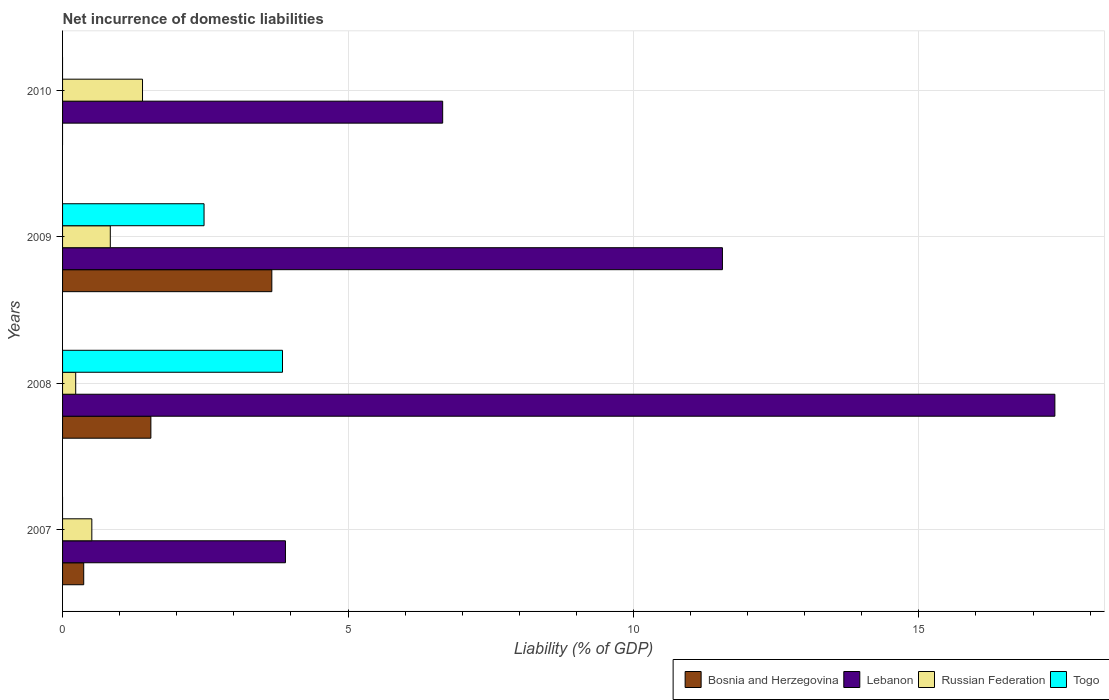Are the number of bars per tick equal to the number of legend labels?
Your answer should be compact. No. How many bars are there on the 3rd tick from the bottom?
Provide a succinct answer. 4. What is the label of the 1st group of bars from the top?
Give a very brief answer. 2010. In how many cases, is the number of bars for a given year not equal to the number of legend labels?
Provide a succinct answer. 2. Across all years, what is the maximum net incurrence of domestic liabilities in Bosnia and Herzegovina?
Your answer should be very brief. 3.67. Across all years, what is the minimum net incurrence of domestic liabilities in Lebanon?
Your response must be concise. 3.9. What is the total net incurrence of domestic liabilities in Bosnia and Herzegovina in the graph?
Your response must be concise. 5.58. What is the difference between the net incurrence of domestic liabilities in Russian Federation in 2007 and that in 2010?
Ensure brevity in your answer.  -0.89. What is the difference between the net incurrence of domestic liabilities in Togo in 2008 and the net incurrence of domestic liabilities in Bosnia and Herzegovina in 2007?
Your answer should be very brief. 3.48. What is the average net incurrence of domestic liabilities in Russian Federation per year?
Provide a short and direct response. 0.74. In the year 2008, what is the difference between the net incurrence of domestic liabilities in Lebanon and net incurrence of domestic liabilities in Togo?
Provide a short and direct response. 13.53. In how many years, is the net incurrence of domestic liabilities in Lebanon greater than 5 %?
Keep it short and to the point. 3. What is the ratio of the net incurrence of domestic liabilities in Bosnia and Herzegovina in 2007 to that in 2009?
Your answer should be compact. 0.1. What is the difference between the highest and the second highest net incurrence of domestic liabilities in Bosnia and Herzegovina?
Keep it short and to the point. 2.12. What is the difference between the highest and the lowest net incurrence of domestic liabilities in Lebanon?
Provide a succinct answer. 13.48. In how many years, is the net incurrence of domestic liabilities in Lebanon greater than the average net incurrence of domestic liabilities in Lebanon taken over all years?
Give a very brief answer. 2. Is the sum of the net incurrence of domestic liabilities in Russian Federation in 2009 and 2010 greater than the maximum net incurrence of domestic liabilities in Bosnia and Herzegovina across all years?
Your response must be concise. No. Is it the case that in every year, the sum of the net incurrence of domestic liabilities in Bosnia and Herzegovina and net incurrence of domestic liabilities in Togo is greater than the sum of net incurrence of domestic liabilities in Lebanon and net incurrence of domestic liabilities in Russian Federation?
Keep it short and to the point. No. Is it the case that in every year, the sum of the net incurrence of domestic liabilities in Russian Federation and net incurrence of domestic liabilities in Togo is greater than the net incurrence of domestic liabilities in Lebanon?
Keep it short and to the point. No. Are all the bars in the graph horizontal?
Offer a very short reply. Yes. How many years are there in the graph?
Give a very brief answer. 4. What is the difference between two consecutive major ticks on the X-axis?
Give a very brief answer. 5. Does the graph contain grids?
Ensure brevity in your answer.  Yes. Where does the legend appear in the graph?
Your answer should be very brief. Bottom right. What is the title of the graph?
Offer a terse response. Net incurrence of domestic liabilities. Does "Antigua and Barbuda" appear as one of the legend labels in the graph?
Ensure brevity in your answer.  No. What is the label or title of the X-axis?
Make the answer very short. Liability (% of GDP). What is the Liability (% of GDP) of Bosnia and Herzegovina in 2007?
Your response must be concise. 0.37. What is the Liability (% of GDP) in Lebanon in 2007?
Make the answer very short. 3.9. What is the Liability (% of GDP) of Russian Federation in 2007?
Provide a succinct answer. 0.51. What is the Liability (% of GDP) of Bosnia and Herzegovina in 2008?
Your answer should be very brief. 1.55. What is the Liability (% of GDP) in Lebanon in 2008?
Keep it short and to the point. 17.38. What is the Liability (% of GDP) of Russian Federation in 2008?
Give a very brief answer. 0.23. What is the Liability (% of GDP) in Togo in 2008?
Offer a very short reply. 3.85. What is the Liability (% of GDP) in Bosnia and Herzegovina in 2009?
Offer a very short reply. 3.67. What is the Liability (% of GDP) of Lebanon in 2009?
Your response must be concise. 11.56. What is the Liability (% of GDP) of Russian Federation in 2009?
Keep it short and to the point. 0.84. What is the Liability (% of GDP) in Togo in 2009?
Give a very brief answer. 2.48. What is the Liability (% of GDP) in Lebanon in 2010?
Give a very brief answer. 6.66. What is the Liability (% of GDP) of Russian Federation in 2010?
Give a very brief answer. 1.4. Across all years, what is the maximum Liability (% of GDP) of Bosnia and Herzegovina?
Your answer should be compact. 3.67. Across all years, what is the maximum Liability (% of GDP) in Lebanon?
Your answer should be compact. 17.38. Across all years, what is the maximum Liability (% of GDP) in Russian Federation?
Offer a very short reply. 1.4. Across all years, what is the maximum Liability (% of GDP) in Togo?
Provide a short and direct response. 3.85. Across all years, what is the minimum Liability (% of GDP) of Bosnia and Herzegovina?
Ensure brevity in your answer.  0. Across all years, what is the minimum Liability (% of GDP) of Lebanon?
Provide a succinct answer. 3.9. Across all years, what is the minimum Liability (% of GDP) of Russian Federation?
Ensure brevity in your answer.  0.23. What is the total Liability (% of GDP) of Bosnia and Herzegovina in the graph?
Your response must be concise. 5.58. What is the total Liability (% of GDP) in Lebanon in the graph?
Your answer should be compact. 39.51. What is the total Liability (% of GDP) of Russian Federation in the graph?
Provide a short and direct response. 2.98. What is the total Liability (% of GDP) in Togo in the graph?
Your answer should be very brief. 6.33. What is the difference between the Liability (% of GDP) in Bosnia and Herzegovina in 2007 and that in 2008?
Your response must be concise. -1.18. What is the difference between the Liability (% of GDP) in Lebanon in 2007 and that in 2008?
Provide a short and direct response. -13.48. What is the difference between the Liability (% of GDP) of Russian Federation in 2007 and that in 2008?
Offer a very short reply. 0.28. What is the difference between the Liability (% of GDP) of Bosnia and Herzegovina in 2007 and that in 2009?
Provide a short and direct response. -3.3. What is the difference between the Liability (% of GDP) in Lebanon in 2007 and that in 2009?
Your answer should be very brief. -7.65. What is the difference between the Liability (% of GDP) of Russian Federation in 2007 and that in 2009?
Keep it short and to the point. -0.32. What is the difference between the Liability (% of GDP) in Lebanon in 2007 and that in 2010?
Ensure brevity in your answer.  -2.75. What is the difference between the Liability (% of GDP) of Russian Federation in 2007 and that in 2010?
Provide a short and direct response. -0.89. What is the difference between the Liability (% of GDP) of Bosnia and Herzegovina in 2008 and that in 2009?
Ensure brevity in your answer.  -2.12. What is the difference between the Liability (% of GDP) in Lebanon in 2008 and that in 2009?
Keep it short and to the point. 5.82. What is the difference between the Liability (% of GDP) in Russian Federation in 2008 and that in 2009?
Make the answer very short. -0.61. What is the difference between the Liability (% of GDP) of Togo in 2008 and that in 2009?
Your answer should be very brief. 1.37. What is the difference between the Liability (% of GDP) of Lebanon in 2008 and that in 2010?
Make the answer very short. 10.72. What is the difference between the Liability (% of GDP) of Russian Federation in 2008 and that in 2010?
Give a very brief answer. -1.17. What is the difference between the Liability (% of GDP) of Lebanon in 2009 and that in 2010?
Ensure brevity in your answer.  4.9. What is the difference between the Liability (% of GDP) in Russian Federation in 2009 and that in 2010?
Offer a terse response. -0.56. What is the difference between the Liability (% of GDP) in Bosnia and Herzegovina in 2007 and the Liability (% of GDP) in Lebanon in 2008?
Provide a short and direct response. -17.01. What is the difference between the Liability (% of GDP) of Bosnia and Herzegovina in 2007 and the Liability (% of GDP) of Russian Federation in 2008?
Provide a short and direct response. 0.14. What is the difference between the Liability (% of GDP) of Bosnia and Herzegovina in 2007 and the Liability (% of GDP) of Togo in 2008?
Your answer should be very brief. -3.48. What is the difference between the Liability (% of GDP) of Lebanon in 2007 and the Liability (% of GDP) of Russian Federation in 2008?
Give a very brief answer. 3.67. What is the difference between the Liability (% of GDP) in Lebanon in 2007 and the Liability (% of GDP) in Togo in 2008?
Offer a very short reply. 0.05. What is the difference between the Liability (% of GDP) of Russian Federation in 2007 and the Liability (% of GDP) of Togo in 2008?
Give a very brief answer. -3.34. What is the difference between the Liability (% of GDP) in Bosnia and Herzegovina in 2007 and the Liability (% of GDP) in Lebanon in 2009?
Ensure brevity in your answer.  -11.19. What is the difference between the Liability (% of GDP) of Bosnia and Herzegovina in 2007 and the Liability (% of GDP) of Russian Federation in 2009?
Give a very brief answer. -0.47. What is the difference between the Liability (% of GDP) of Bosnia and Herzegovina in 2007 and the Liability (% of GDP) of Togo in 2009?
Offer a very short reply. -2.11. What is the difference between the Liability (% of GDP) in Lebanon in 2007 and the Liability (% of GDP) in Russian Federation in 2009?
Ensure brevity in your answer.  3.07. What is the difference between the Liability (% of GDP) of Lebanon in 2007 and the Liability (% of GDP) of Togo in 2009?
Keep it short and to the point. 1.43. What is the difference between the Liability (% of GDP) in Russian Federation in 2007 and the Liability (% of GDP) in Togo in 2009?
Give a very brief answer. -1.97. What is the difference between the Liability (% of GDP) of Bosnia and Herzegovina in 2007 and the Liability (% of GDP) of Lebanon in 2010?
Offer a very short reply. -6.29. What is the difference between the Liability (% of GDP) in Bosnia and Herzegovina in 2007 and the Liability (% of GDP) in Russian Federation in 2010?
Your answer should be very brief. -1.03. What is the difference between the Liability (% of GDP) of Lebanon in 2007 and the Liability (% of GDP) of Russian Federation in 2010?
Keep it short and to the point. 2.5. What is the difference between the Liability (% of GDP) of Bosnia and Herzegovina in 2008 and the Liability (% of GDP) of Lebanon in 2009?
Provide a succinct answer. -10.01. What is the difference between the Liability (% of GDP) in Bosnia and Herzegovina in 2008 and the Liability (% of GDP) in Russian Federation in 2009?
Keep it short and to the point. 0.71. What is the difference between the Liability (% of GDP) of Bosnia and Herzegovina in 2008 and the Liability (% of GDP) of Togo in 2009?
Provide a short and direct response. -0.93. What is the difference between the Liability (% of GDP) of Lebanon in 2008 and the Liability (% of GDP) of Russian Federation in 2009?
Give a very brief answer. 16.55. What is the difference between the Liability (% of GDP) of Lebanon in 2008 and the Liability (% of GDP) of Togo in 2009?
Offer a terse response. 14.9. What is the difference between the Liability (% of GDP) in Russian Federation in 2008 and the Liability (% of GDP) in Togo in 2009?
Your answer should be very brief. -2.25. What is the difference between the Liability (% of GDP) in Bosnia and Herzegovina in 2008 and the Liability (% of GDP) in Lebanon in 2010?
Provide a short and direct response. -5.11. What is the difference between the Liability (% of GDP) in Bosnia and Herzegovina in 2008 and the Liability (% of GDP) in Russian Federation in 2010?
Provide a succinct answer. 0.15. What is the difference between the Liability (% of GDP) in Lebanon in 2008 and the Liability (% of GDP) in Russian Federation in 2010?
Make the answer very short. 15.98. What is the difference between the Liability (% of GDP) of Bosnia and Herzegovina in 2009 and the Liability (% of GDP) of Lebanon in 2010?
Keep it short and to the point. -2.99. What is the difference between the Liability (% of GDP) of Bosnia and Herzegovina in 2009 and the Liability (% of GDP) of Russian Federation in 2010?
Give a very brief answer. 2.27. What is the difference between the Liability (% of GDP) of Lebanon in 2009 and the Liability (% of GDP) of Russian Federation in 2010?
Give a very brief answer. 10.16. What is the average Liability (% of GDP) of Bosnia and Herzegovina per year?
Provide a short and direct response. 1.4. What is the average Liability (% of GDP) in Lebanon per year?
Provide a succinct answer. 9.88. What is the average Liability (% of GDP) of Russian Federation per year?
Your answer should be compact. 0.74. What is the average Liability (% of GDP) in Togo per year?
Offer a terse response. 1.58. In the year 2007, what is the difference between the Liability (% of GDP) in Bosnia and Herzegovina and Liability (% of GDP) in Lebanon?
Ensure brevity in your answer.  -3.53. In the year 2007, what is the difference between the Liability (% of GDP) in Bosnia and Herzegovina and Liability (% of GDP) in Russian Federation?
Ensure brevity in your answer.  -0.14. In the year 2007, what is the difference between the Liability (% of GDP) of Lebanon and Liability (% of GDP) of Russian Federation?
Offer a terse response. 3.39. In the year 2008, what is the difference between the Liability (% of GDP) in Bosnia and Herzegovina and Liability (% of GDP) in Lebanon?
Your answer should be compact. -15.84. In the year 2008, what is the difference between the Liability (% of GDP) in Bosnia and Herzegovina and Liability (% of GDP) in Russian Federation?
Your answer should be very brief. 1.32. In the year 2008, what is the difference between the Liability (% of GDP) in Bosnia and Herzegovina and Liability (% of GDP) in Togo?
Offer a very short reply. -2.31. In the year 2008, what is the difference between the Liability (% of GDP) in Lebanon and Liability (% of GDP) in Russian Federation?
Make the answer very short. 17.15. In the year 2008, what is the difference between the Liability (% of GDP) in Lebanon and Liability (% of GDP) in Togo?
Your response must be concise. 13.53. In the year 2008, what is the difference between the Liability (% of GDP) of Russian Federation and Liability (% of GDP) of Togo?
Offer a very short reply. -3.62. In the year 2009, what is the difference between the Liability (% of GDP) in Bosnia and Herzegovina and Liability (% of GDP) in Lebanon?
Ensure brevity in your answer.  -7.89. In the year 2009, what is the difference between the Liability (% of GDP) in Bosnia and Herzegovina and Liability (% of GDP) in Russian Federation?
Offer a very short reply. 2.83. In the year 2009, what is the difference between the Liability (% of GDP) in Bosnia and Herzegovina and Liability (% of GDP) in Togo?
Offer a very short reply. 1.19. In the year 2009, what is the difference between the Liability (% of GDP) in Lebanon and Liability (% of GDP) in Russian Federation?
Keep it short and to the point. 10.72. In the year 2009, what is the difference between the Liability (% of GDP) of Lebanon and Liability (% of GDP) of Togo?
Ensure brevity in your answer.  9.08. In the year 2009, what is the difference between the Liability (% of GDP) in Russian Federation and Liability (% of GDP) in Togo?
Your answer should be compact. -1.64. In the year 2010, what is the difference between the Liability (% of GDP) of Lebanon and Liability (% of GDP) of Russian Federation?
Give a very brief answer. 5.26. What is the ratio of the Liability (% of GDP) of Bosnia and Herzegovina in 2007 to that in 2008?
Provide a short and direct response. 0.24. What is the ratio of the Liability (% of GDP) in Lebanon in 2007 to that in 2008?
Your answer should be compact. 0.22. What is the ratio of the Liability (% of GDP) of Russian Federation in 2007 to that in 2008?
Give a very brief answer. 2.23. What is the ratio of the Liability (% of GDP) in Bosnia and Herzegovina in 2007 to that in 2009?
Ensure brevity in your answer.  0.1. What is the ratio of the Liability (% of GDP) in Lebanon in 2007 to that in 2009?
Offer a very short reply. 0.34. What is the ratio of the Liability (% of GDP) of Russian Federation in 2007 to that in 2009?
Your answer should be compact. 0.61. What is the ratio of the Liability (% of GDP) of Lebanon in 2007 to that in 2010?
Offer a very short reply. 0.59. What is the ratio of the Liability (% of GDP) of Russian Federation in 2007 to that in 2010?
Provide a short and direct response. 0.37. What is the ratio of the Liability (% of GDP) in Bosnia and Herzegovina in 2008 to that in 2009?
Offer a terse response. 0.42. What is the ratio of the Liability (% of GDP) in Lebanon in 2008 to that in 2009?
Make the answer very short. 1.5. What is the ratio of the Liability (% of GDP) of Russian Federation in 2008 to that in 2009?
Offer a very short reply. 0.28. What is the ratio of the Liability (% of GDP) in Togo in 2008 to that in 2009?
Offer a very short reply. 1.55. What is the ratio of the Liability (% of GDP) in Lebanon in 2008 to that in 2010?
Provide a succinct answer. 2.61. What is the ratio of the Liability (% of GDP) of Russian Federation in 2008 to that in 2010?
Give a very brief answer. 0.16. What is the ratio of the Liability (% of GDP) of Lebanon in 2009 to that in 2010?
Your response must be concise. 1.74. What is the ratio of the Liability (% of GDP) of Russian Federation in 2009 to that in 2010?
Offer a very short reply. 0.6. What is the difference between the highest and the second highest Liability (% of GDP) in Bosnia and Herzegovina?
Ensure brevity in your answer.  2.12. What is the difference between the highest and the second highest Liability (% of GDP) of Lebanon?
Offer a terse response. 5.82. What is the difference between the highest and the second highest Liability (% of GDP) of Russian Federation?
Offer a terse response. 0.56. What is the difference between the highest and the lowest Liability (% of GDP) in Bosnia and Herzegovina?
Ensure brevity in your answer.  3.67. What is the difference between the highest and the lowest Liability (% of GDP) in Lebanon?
Provide a short and direct response. 13.48. What is the difference between the highest and the lowest Liability (% of GDP) of Russian Federation?
Provide a short and direct response. 1.17. What is the difference between the highest and the lowest Liability (% of GDP) in Togo?
Your response must be concise. 3.85. 